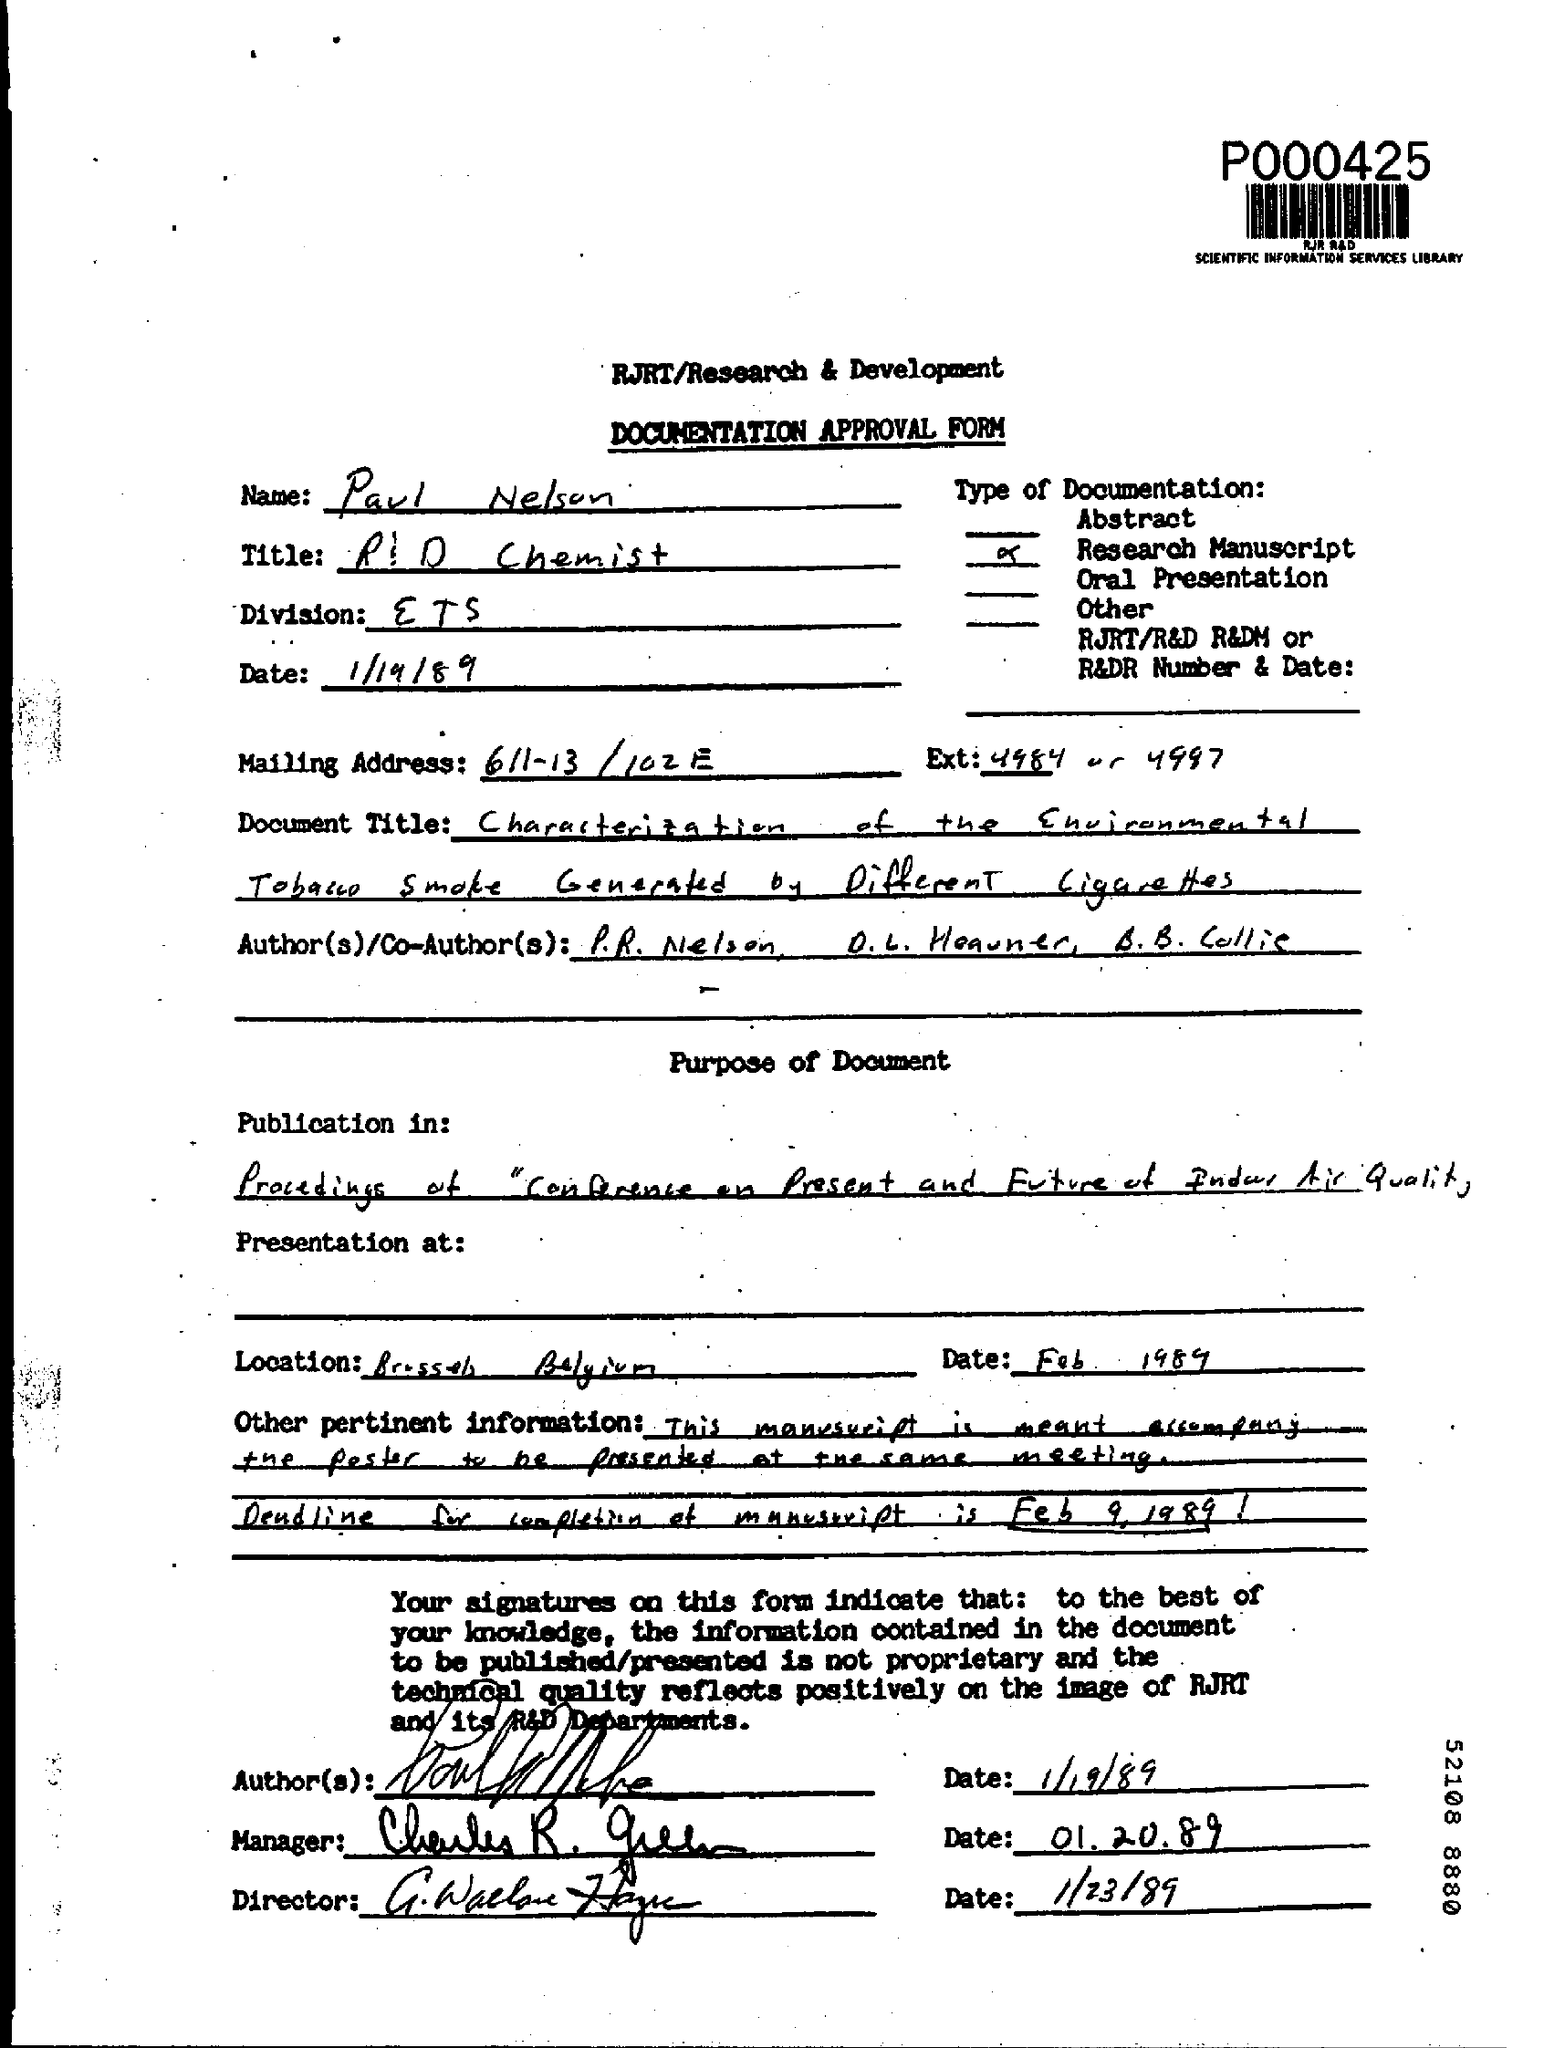Identify some key points in this picture. The date mentioned at the top of the document is 1/19/89. The Division field contains the text 'ETS..'. 